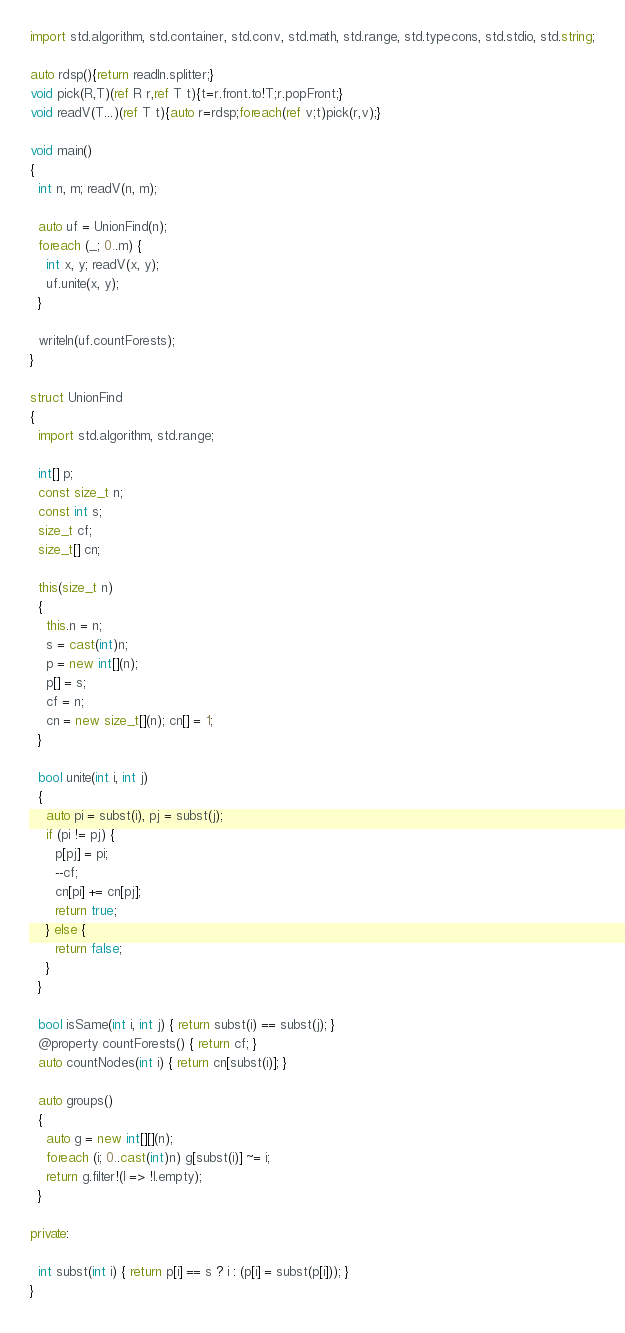<code> <loc_0><loc_0><loc_500><loc_500><_D_>import std.algorithm, std.container, std.conv, std.math, std.range, std.typecons, std.stdio, std.string;

auto rdsp(){return readln.splitter;}
void pick(R,T)(ref R r,ref T t){t=r.front.to!T;r.popFront;}
void readV(T...)(ref T t){auto r=rdsp;foreach(ref v;t)pick(r,v);}

void main()
{
  int n, m; readV(n, m);

  auto uf = UnionFind(n);
  foreach (_; 0..m) {
    int x, y; readV(x, y);
    uf.unite(x, y);
  }

  writeln(uf.countForests);
}

struct UnionFind
{
  import std.algorithm, std.range;

  int[] p;
  const size_t n;
  const int s;
  size_t cf;
  size_t[] cn;

  this(size_t n)
  {
    this.n = n;
    s = cast(int)n;
    p = new int[](n);
    p[] = s;
    cf = n;
    cn = new size_t[](n); cn[] = 1;
  }

  bool unite(int i, int j)
  {
    auto pi = subst(i), pj = subst(j);
    if (pi != pj) {
      p[pj] = pi;
      --cf;
      cn[pi] += cn[pj];
      return true;
    } else {
      return false;
    }
  }

  bool isSame(int i, int j) { return subst(i) == subst(j); }
  @property countForests() { return cf; }
  auto countNodes(int i) { return cn[subst(i)]; }

  auto groups()
  {
    auto g = new int[][](n);
    foreach (i; 0..cast(int)n) g[subst(i)] ~= i;
    return g.filter!(l => !l.empty);
  }

private:

  int subst(int i) { return p[i] == s ? i : (p[i] = subst(p[i])); }
}
</code> 